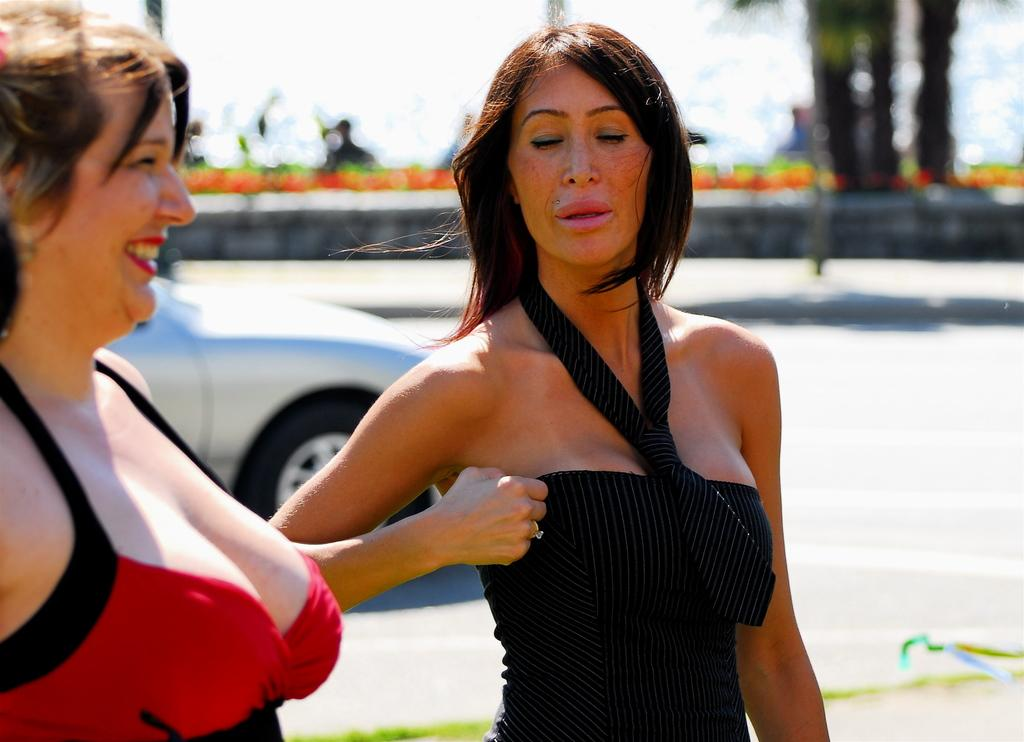How many women are present in the image? There are two women standing in the image. Can you describe the facial expression of one of the women? The woman on the left side is smiling. What can be seen in the background of the image? There is a car in the background of the image. How would you describe the clarity of the background? The background appears blurry. What type of steam is coming out of the car in the image? There is no steam coming out of the car in the image, as it is not mentioned in the provided facts. 